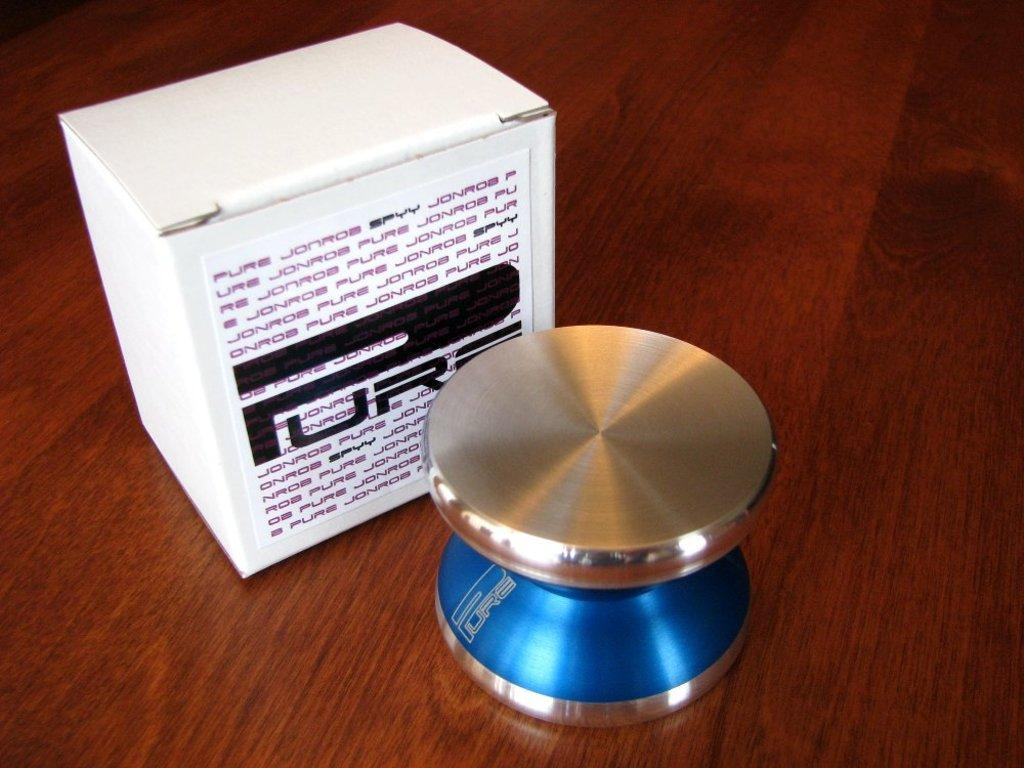Provide a one-sentence caption for the provided image. A device that could be either a metallic yo-yo or a tech device sits on a wooden surface and it's box labeled "PURE" sits behind it. 